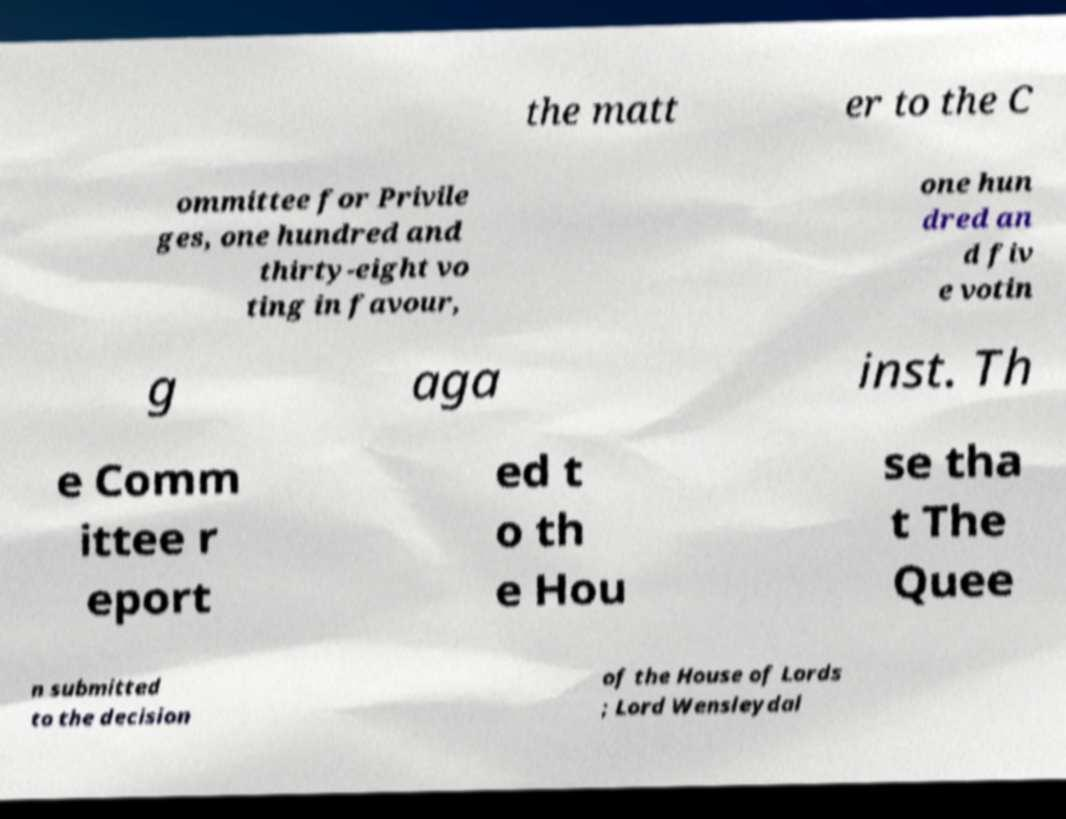Please identify and transcribe the text found in this image. the matt er to the C ommittee for Privile ges, one hundred and thirty-eight vo ting in favour, one hun dred an d fiv e votin g aga inst. Th e Comm ittee r eport ed t o th e Hou se tha t The Quee n submitted to the decision of the House of Lords ; Lord Wensleydal 